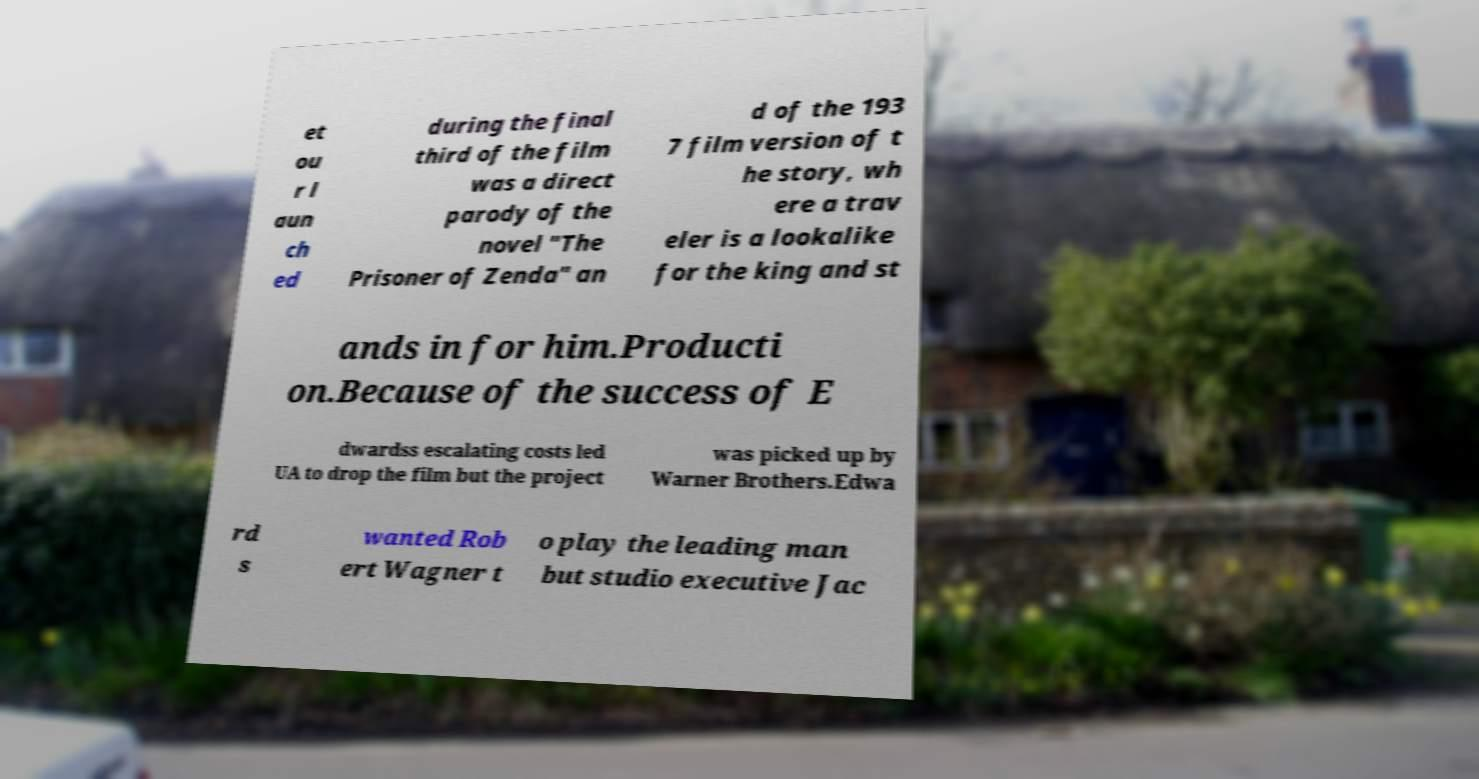Please read and relay the text visible in this image. What does it say? et ou r l aun ch ed during the final third of the film was a direct parody of the novel "The Prisoner of Zenda" an d of the 193 7 film version of t he story, wh ere a trav eler is a lookalike for the king and st ands in for him.Producti on.Because of the success of E dwardss escalating costs led UA to drop the film but the project was picked up by Warner Brothers.Edwa rd s wanted Rob ert Wagner t o play the leading man but studio executive Jac 